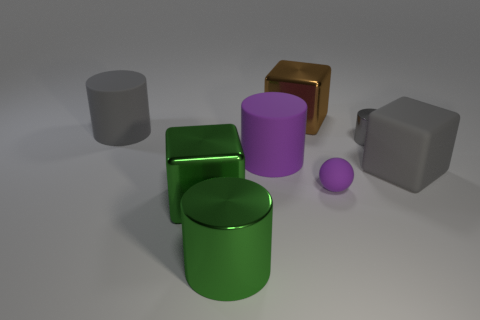Do the gray thing that is behind the small gray metallic cylinder and the gray metallic thing that is on the right side of the big purple rubber thing have the same shape?
Make the answer very short. Yes. How many things are purple metal spheres or objects on the right side of the tiny cylinder?
Offer a terse response. 1. What number of other things are there of the same shape as the large purple thing?
Give a very brief answer. 3. Are the cylinder that is in front of the small sphere and the tiny sphere made of the same material?
Provide a short and direct response. No. How many things are either cyan shiny things or large cylinders?
Ensure brevity in your answer.  3. What is the size of the gray metallic thing that is the same shape as the big purple rubber object?
Your response must be concise. Small. What is the size of the gray matte cylinder?
Offer a terse response. Large. Is the number of objects in front of the green block greater than the number of small gray rubber cylinders?
Make the answer very short. Yes. There is a small matte sphere on the left side of the large rubber block; does it have the same color as the rubber cylinder in front of the tiny gray metal thing?
Give a very brief answer. Yes. What material is the large gray object in front of the cylinder to the left of the large green thing that is behind the big shiny cylinder made of?
Make the answer very short. Rubber. 